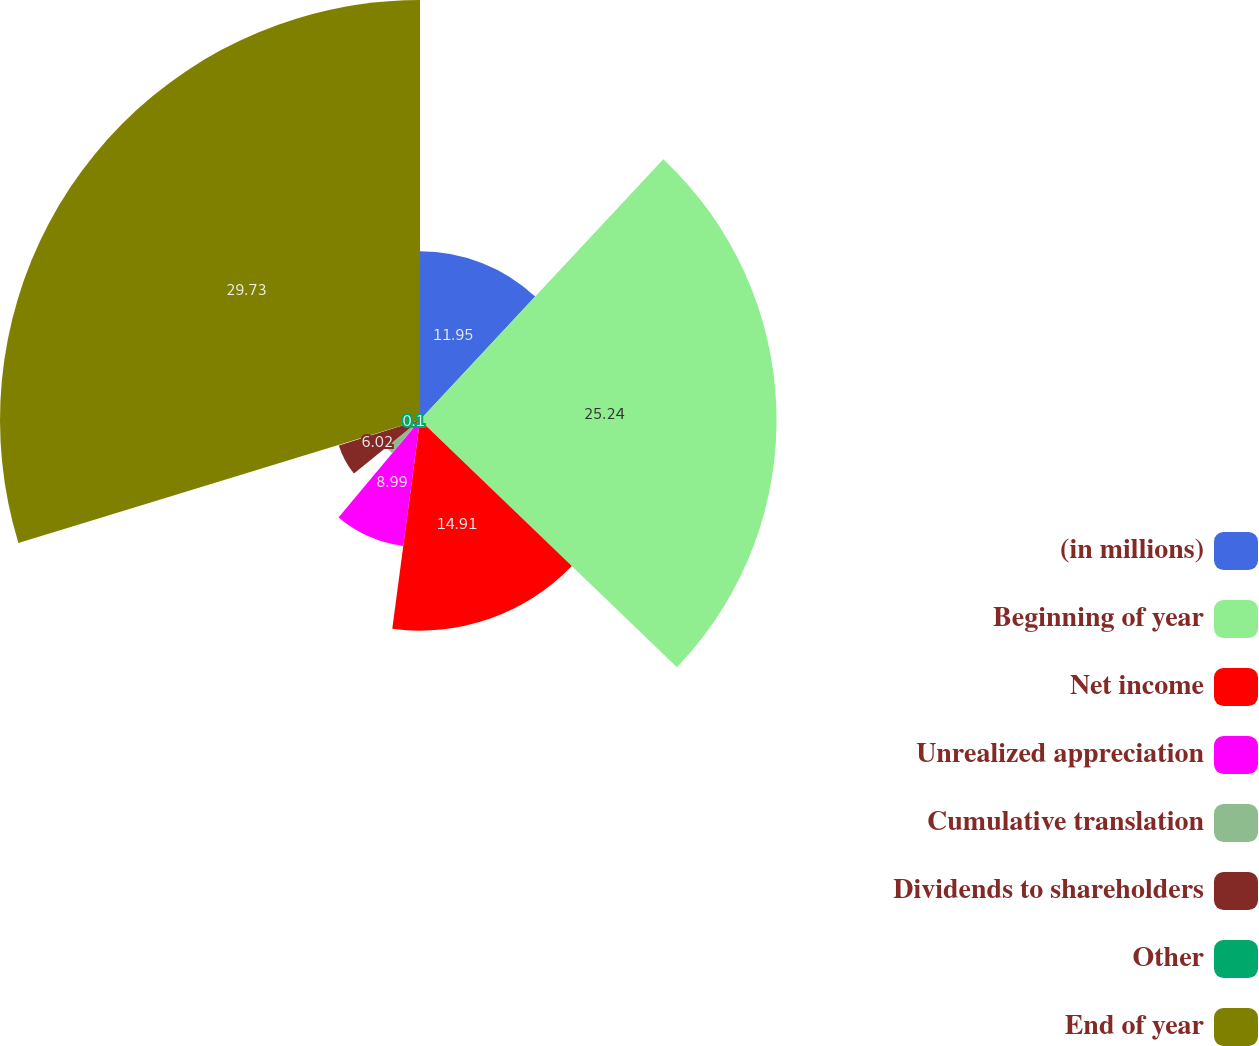<chart> <loc_0><loc_0><loc_500><loc_500><pie_chart><fcel>(in millions)<fcel>Beginning of year<fcel>Net income<fcel>Unrealized appreciation<fcel>Cumulative translation<fcel>Dividends to shareholders<fcel>Other<fcel>End of year<nl><fcel>11.95%<fcel>25.24%<fcel>14.91%<fcel>8.99%<fcel>3.06%<fcel>6.02%<fcel>0.1%<fcel>29.73%<nl></chart> 